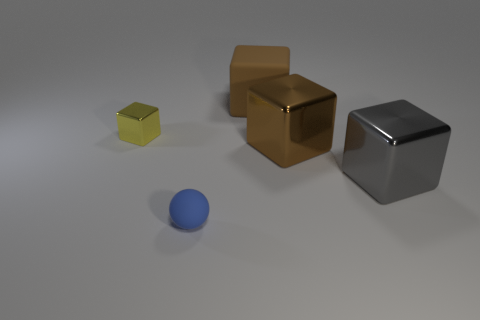Add 2 small yellow objects. How many objects exist? 7 Subtract all tiny cubes. How many cubes are left? 3 Subtract all brown blocks. How many blocks are left? 2 Subtract all yellow metallic objects. Subtract all large brown blocks. How many objects are left? 2 Add 5 yellow metallic objects. How many yellow metallic objects are left? 6 Add 2 blue matte blocks. How many blue matte blocks exist? 2 Subtract 0 gray balls. How many objects are left? 5 Subtract all spheres. How many objects are left? 4 Subtract 2 blocks. How many blocks are left? 2 Subtract all gray cubes. Subtract all blue cylinders. How many cubes are left? 3 